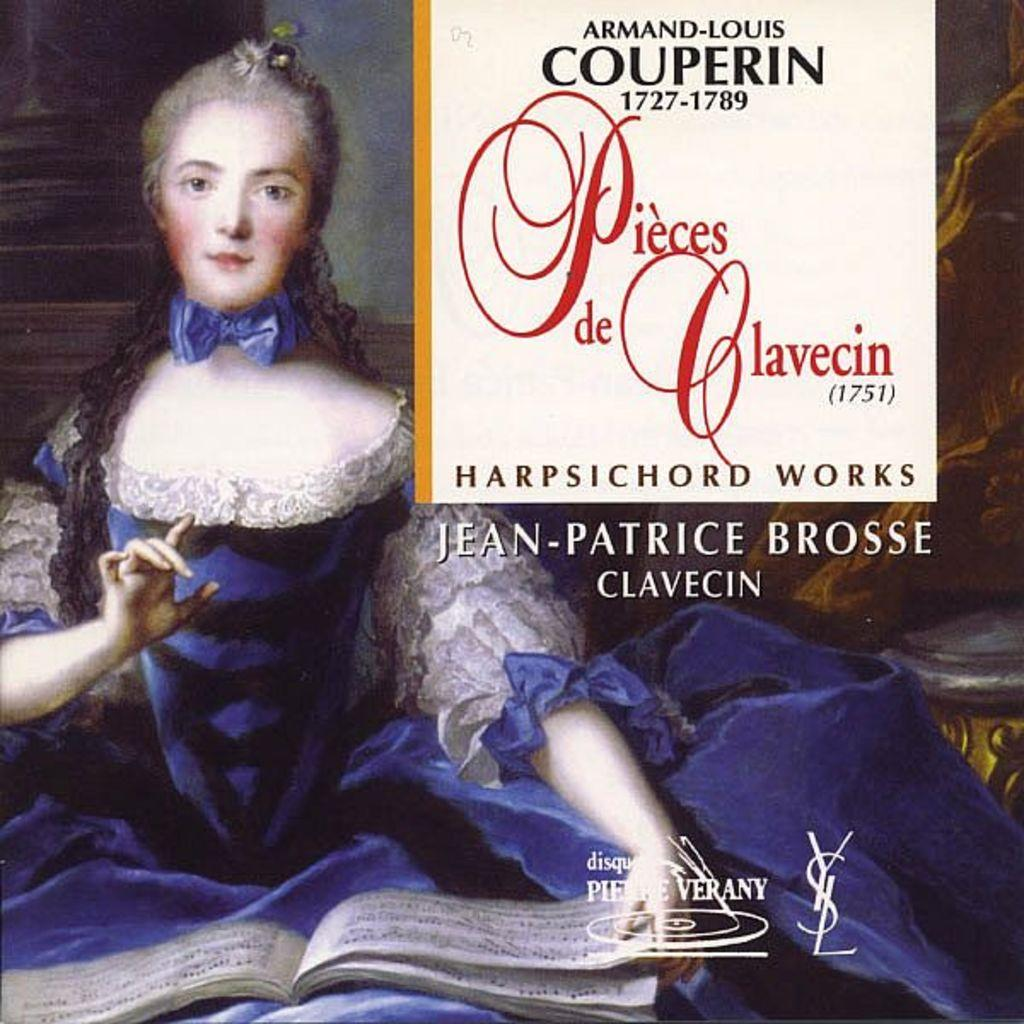<image>
Share a concise interpretation of the image provided. Pieces De Clavecin was written by Jean Patrice Brosse 